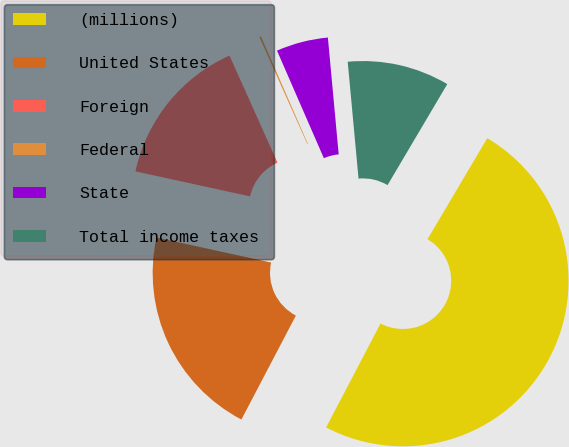<chart> <loc_0><loc_0><loc_500><loc_500><pie_chart><fcel>(millions)<fcel>United States<fcel>Foreign<fcel>Federal<fcel>State<fcel>Total income taxes<nl><fcel>49.18%<fcel>20.74%<fcel>14.87%<fcel>0.17%<fcel>5.07%<fcel>9.97%<nl></chart> 